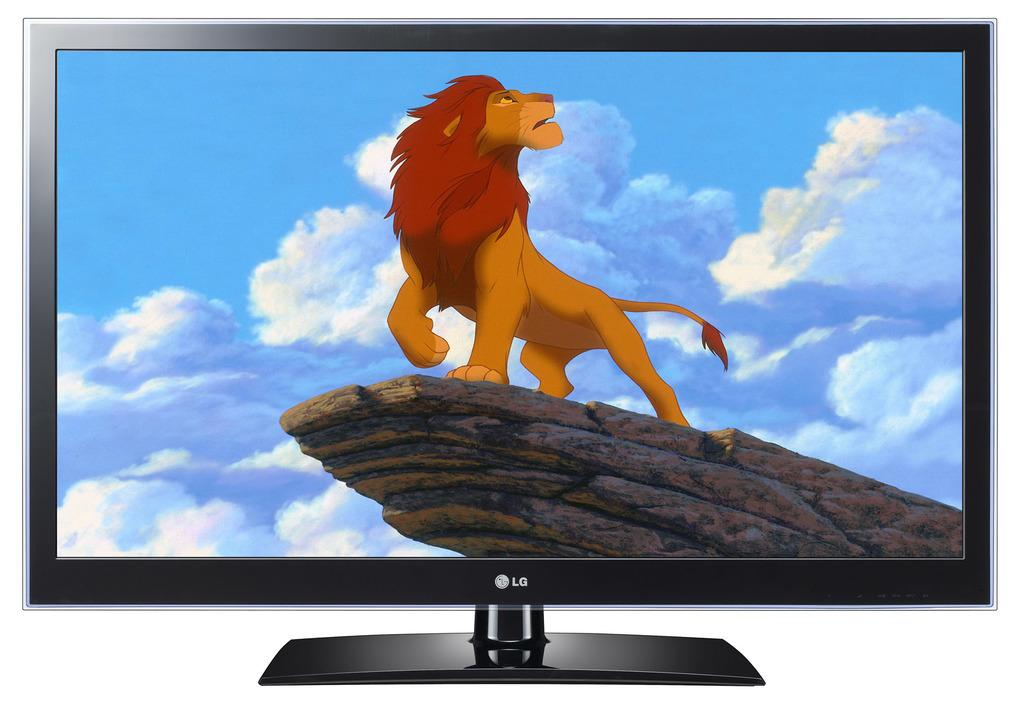<image>
Relay a brief, clear account of the picture shown. An LG brand television displayed with a picture of a lion on the screen. 